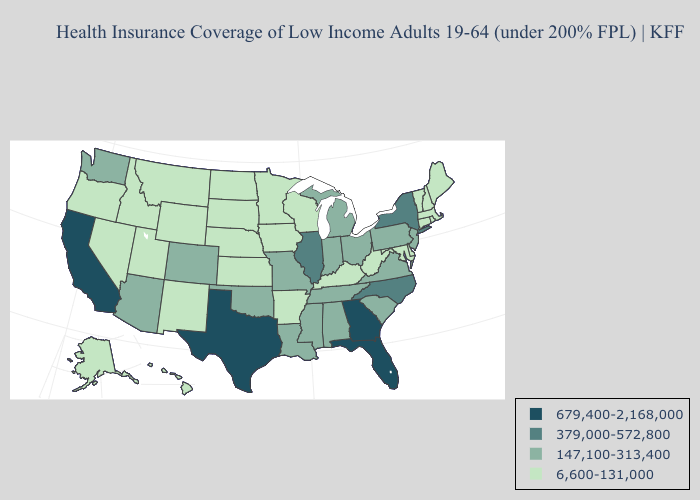What is the value of Delaware?
Answer briefly. 6,600-131,000. Name the states that have a value in the range 679,400-2,168,000?
Concise answer only. California, Florida, Georgia, Texas. Does Alabama have a lower value than Montana?
Be succinct. No. What is the highest value in the MidWest ?
Give a very brief answer. 379,000-572,800. Does Kansas have a higher value than Missouri?
Quick response, please. No. Name the states that have a value in the range 6,600-131,000?
Be succinct. Alaska, Arkansas, Connecticut, Delaware, Hawaii, Idaho, Iowa, Kansas, Kentucky, Maine, Maryland, Massachusetts, Minnesota, Montana, Nebraska, Nevada, New Hampshire, New Mexico, North Dakota, Oregon, Rhode Island, South Dakota, Utah, Vermont, West Virginia, Wisconsin, Wyoming. What is the lowest value in the USA?
Quick response, please. 6,600-131,000. Name the states that have a value in the range 6,600-131,000?
Give a very brief answer. Alaska, Arkansas, Connecticut, Delaware, Hawaii, Idaho, Iowa, Kansas, Kentucky, Maine, Maryland, Massachusetts, Minnesota, Montana, Nebraska, Nevada, New Hampshire, New Mexico, North Dakota, Oregon, Rhode Island, South Dakota, Utah, Vermont, West Virginia, Wisconsin, Wyoming. Does Tennessee have the highest value in the South?
Give a very brief answer. No. What is the lowest value in the MidWest?
Concise answer only. 6,600-131,000. Name the states that have a value in the range 679,400-2,168,000?
Keep it brief. California, Florida, Georgia, Texas. Name the states that have a value in the range 379,000-572,800?
Answer briefly. Illinois, New York, North Carolina. Does New Mexico have a lower value than Arkansas?
Answer briefly. No. Among the states that border Wisconsin , which have the lowest value?
Short answer required. Iowa, Minnesota. 